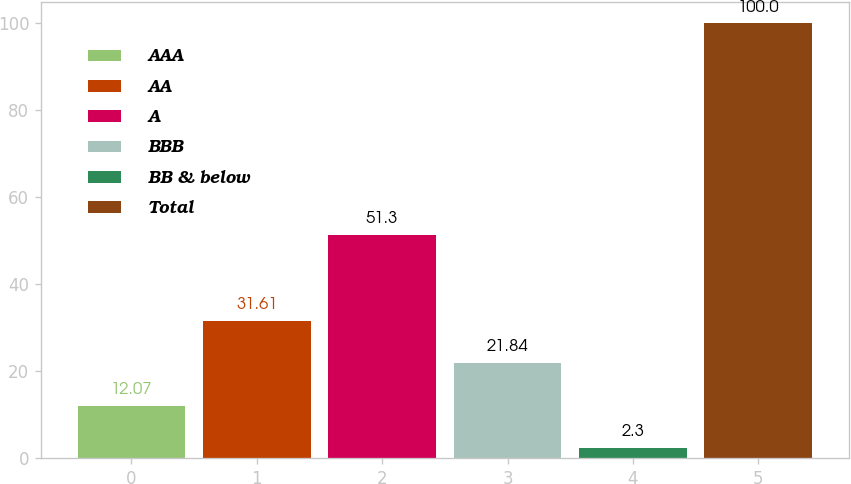Convert chart. <chart><loc_0><loc_0><loc_500><loc_500><bar_chart><fcel>AAA<fcel>AA<fcel>A<fcel>BBB<fcel>BB & below<fcel>Total<nl><fcel>12.07<fcel>31.61<fcel>51.3<fcel>21.84<fcel>2.3<fcel>100<nl></chart> 